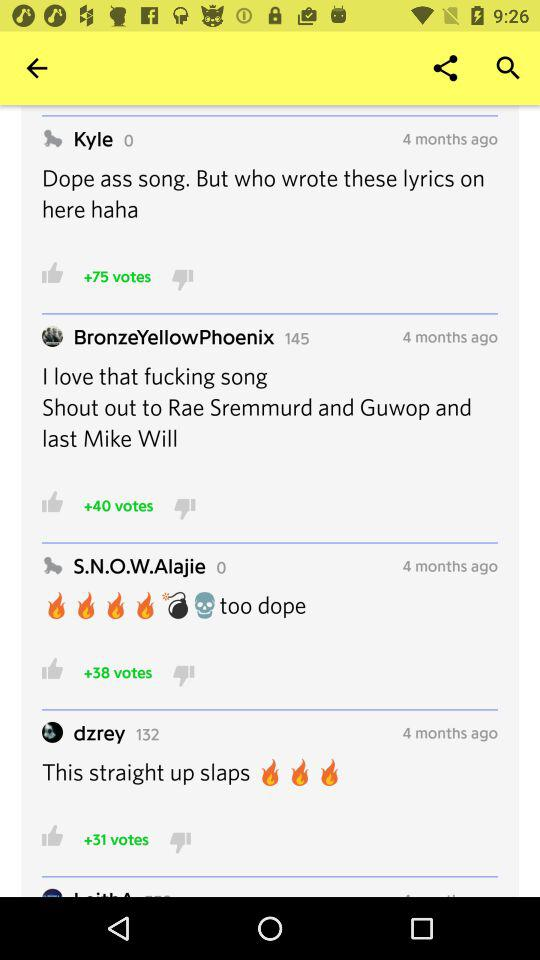How many votes are given to Kyle's comment? There are 75 votes given to Kyle's comment. 